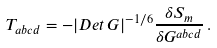Convert formula to latex. <formula><loc_0><loc_0><loc_500><loc_500>T _ { a b c d } = - | D e t \, G | ^ { - 1 / 6 } \frac { \delta S _ { m } } { \delta G ^ { a b c d } } \, .</formula> 